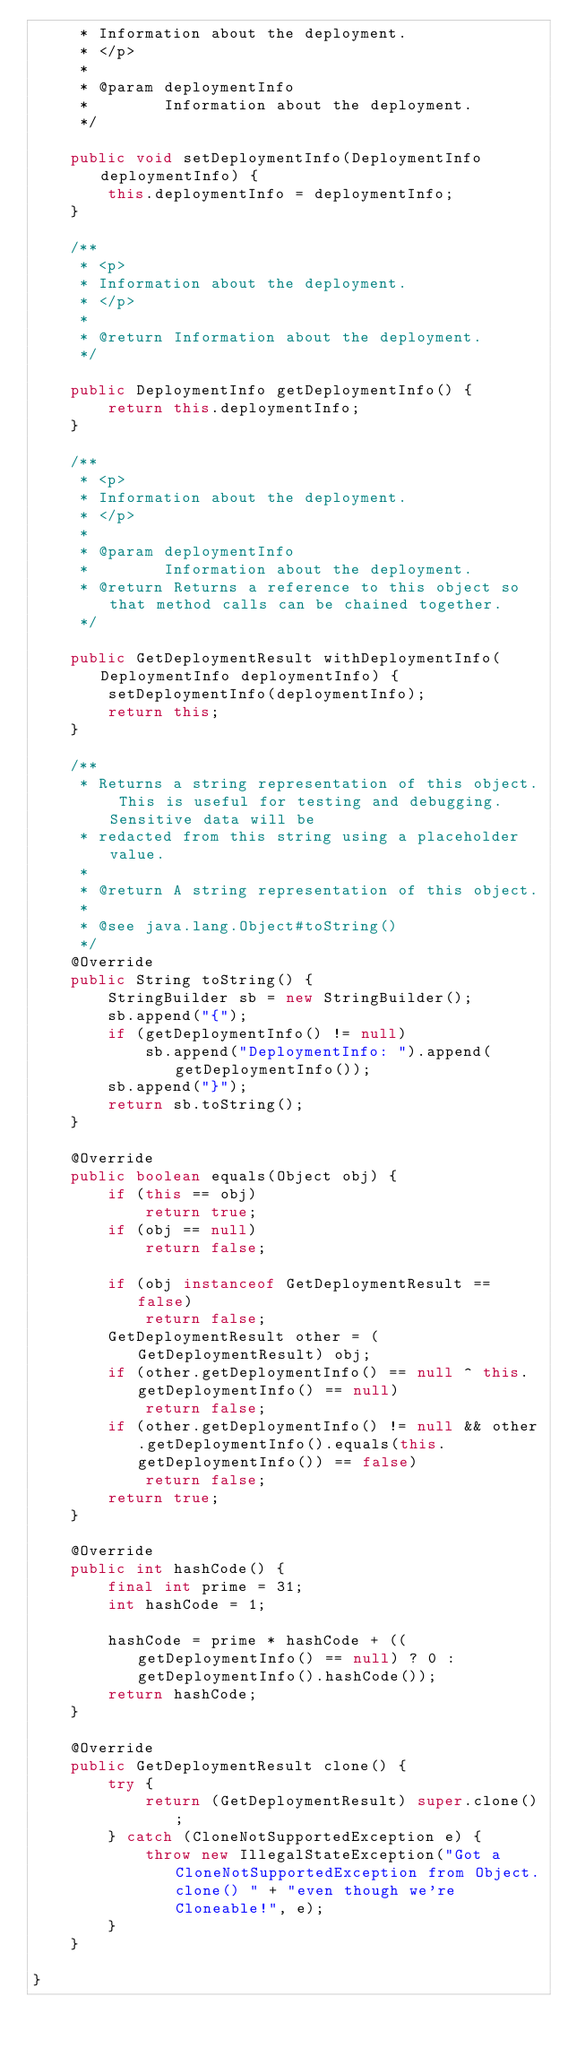Convert code to text. <code><loc_0><loc_0><loc_500><loc_500><_Java_>     * Information about the deployment.
     * </p>
     * 
     * @param deploymentInfo
     *        Information about the deployment.
     */

    public void setDeploymentInfo(DeploymentInfo deploymentInfo) {
        this.deploymentInfo = deploymentInfo;
    }

    /**
     * <p>
     * Information about the deployment.
     * </p>
     * 
     * @return Information about the deployment.
     */

    public DeploymentInfo getDeploymentInfo() {
        return this.deploymentInfo;
    }

    /**
     * <p>
     * Information about the deployment.
     * </p>
     * 
     * @param deploymentInfo
     *        Information about the deployment.
     * @return Returns a reference to this object so that method calls can be chained together.
     */

    public GetDeploymentResult withDeploymentInfo(DeploymentInfo deploymentInfo) {
        setDeploymentInfo(deploymentInfo);
        return this;
    }

    /**
     * Returns a string representation of this object. This is useful for testing and debugging. Sensitive data will be
     * redacted from this string using a placeholder value.
     *
     * @return A string representation of this object.
     *
     * @see java.lang.Object#toString()
     */
    @Override
    public String toString() {
        StringBuilder sb = new StringBuilder();
        sb.append("{");
        if (getDeploymentInfo() != null)
            sb.append("DeploymentInfo: ").append(getDeploymentInfo());
        sb.append("}");
        return sb.toString();
    }

    @Override
    public boolean equals(Object obj) {
        if (this == obj)
            return true;
        if (obj == null)
            return false;

        if (obj instanceof GetDeploymentResult == false)
            return false;
        GetDeploymentResult other = (GetDeploymentResult) obj;
        if (other.getDeploymentInfo() == null ^ this.getDeploymentInfo() == null)
            return false;
        if (other.getDeploymentInfo() != null && other.getDeploymentInfo().equals(this.getDeploymentInfo()) == false)
            return false;
        return true;
    }

    @Override
    public int hashCode() {
        final int prime = 31;
        int hashCode = 1;

        hashCode = prime * hashCode + ((getDeploymentInfo() == null) ? 0 : getDeploymentInfo().hashCode());
        return hashCode;
    }

    @Override
    public GetDeploymentResult clone() {
        try {
            return (GetDeploymentResult) super.clone();
        } catch (CloneNotSupportedException e) {
            throw new IllegalStateException("Got a CloneNotSupportedException from Object.clone() " + "even though we're Cloneable!", e);
        }
    }

}
</code> 